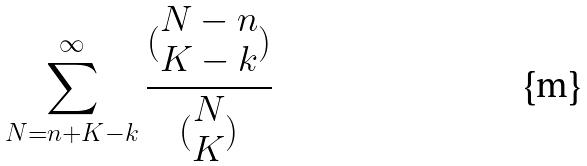Convert formula to latex. <formula><loc_0><loc_0><loc_500><loc_500>\sum _ { N = n + K - k } ^ { \infty } \frac { ( \begin{matrix} N - n \\ K - k \end{matrix} ) } { ( \begin{matrix} N \\ K \end{matrix} ) }</formula> 